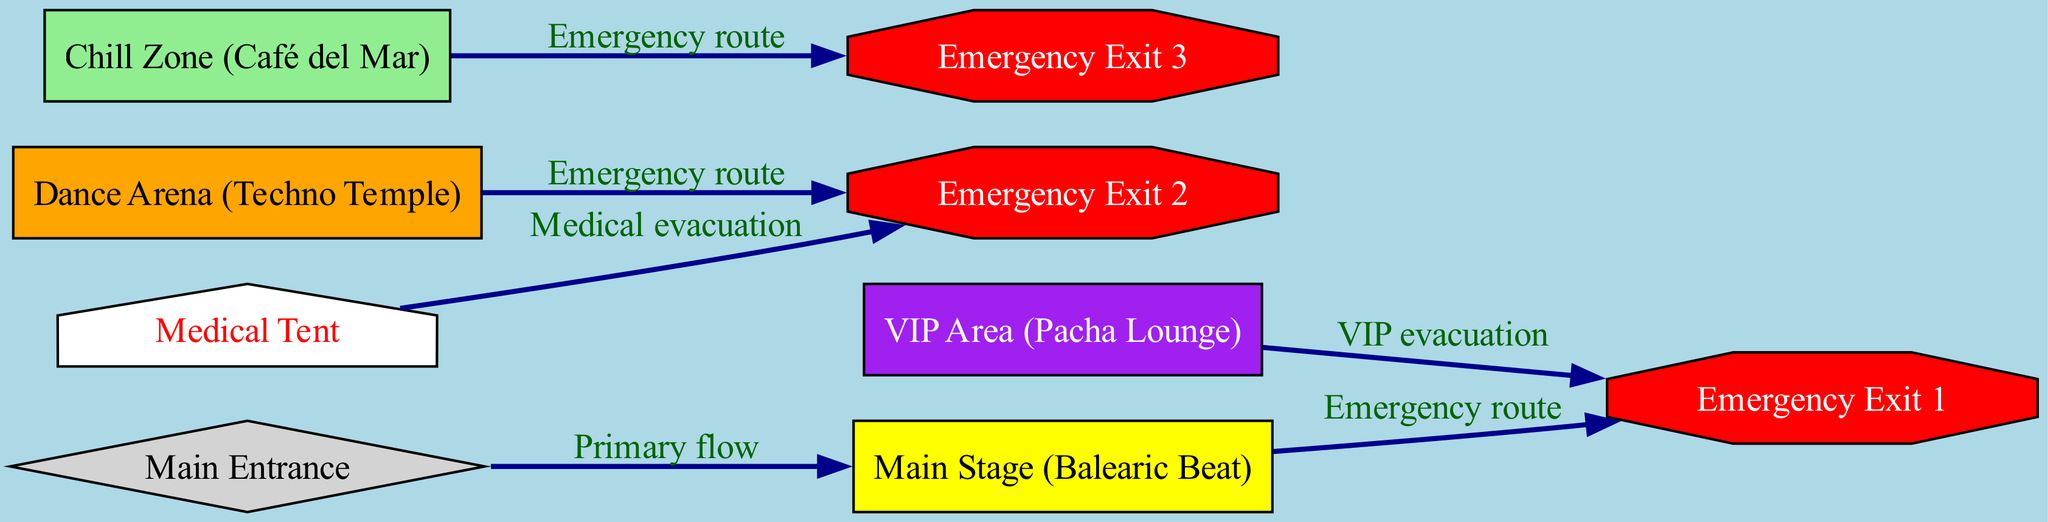What is the total number of nodes in the diagram? By counting the individual nodes listed under "nodes" in the data structure, which include "main_stage", "dance_arena", "chill_zone", "vip_area", "entrance", "exit1", "exit2", "exit3", and "medical", we find there are 9 distinct nodes.
Answer: 9 How many emergency exits are represented in the diagram? The diagram includes three distinct emergency exits, labeled as "exit1", "exit2", and "exit3", which can be identified from the respective nodes in the layout.
Answer: 3 Which area leads directly to Emergency Exit 1? Analyzing the edges, we see that both the "main_stage" and the "vip_area" have direct paths leading to "exit1", as indicated by the labeled connections in the diagram.
Answer: Main Stage and VIP Area What is the label of the node connected to the "main_stage" with a primary flow? The edge originating from "entrance" and leading to "main_stage" shows the primary flow direction. This connection indicates that the node connected to the "main_stage" via the primary flow is "entrance".
Answer: Main Entrance Which node is designated for medical emergencies? The "medical" node is specifically labeled as "Medical Tent", providing an area for medical emergencies within the diagram's layout. This can be directly identified by its label.
Answer: Medical Tent If someone is in the Chill Zone, where is their nearest emergency exit? The "chill_zone" has a direct connection leading to "exit3", making it the nearest emergency exit for individuals in that area, as shown by the respective edge in the diagram.
Answer: Exit 3 Which area is primarily designated for VIPs? The area specifically labeled as "VIP Area" corresponds to "Pacha Lounge" in the diagram, clearly indicating its primary designation for VIP guests at the festival.
Answer: VIP Area What evacuation route do guests from the Dance Arena take during an emergency? Guests located in the "dance_arena" would take the emergency route directly leading them to "exit2", as indicated by the edge representing that particular emergency process.
Answer: Exit 2 What color represents the Chill Zone in the diagram? The "chill_zone" is represented in light green according to the node styling specified within the diagram data, which designates its color uniquely.
Answer: Light Green 